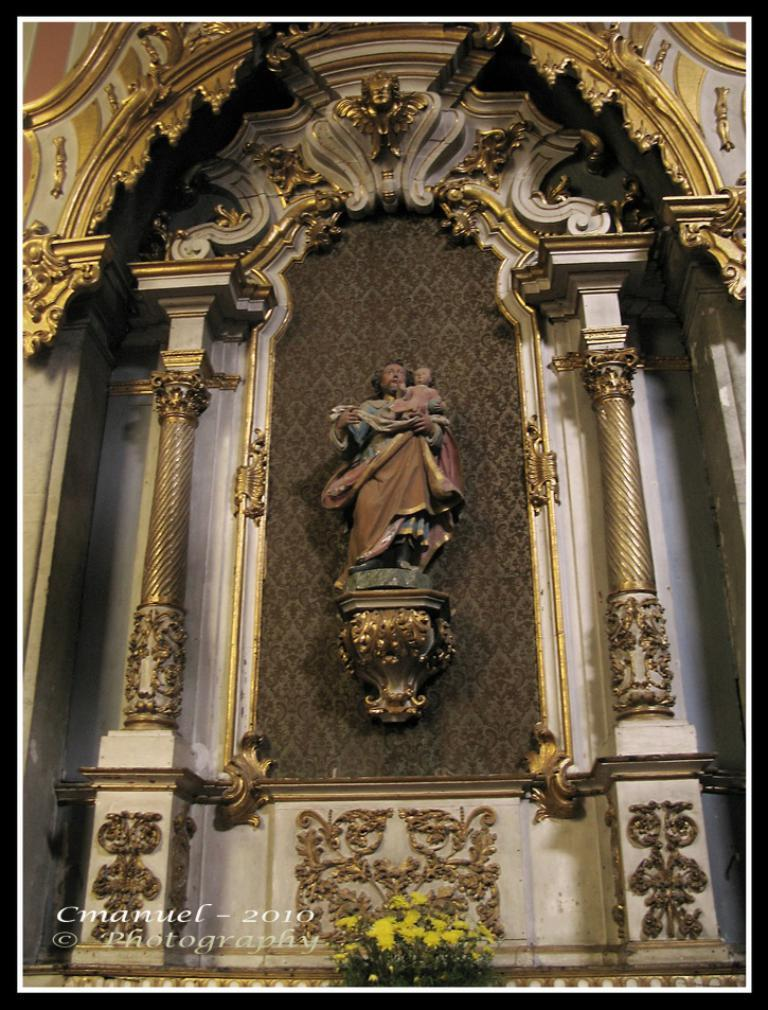What can be seen on the wall in the image? There are sculptures and designs on a wall in the image. What type of natural elements are visible in the image? There are flowers visible in the image. Where is the hydrant located in the image? There is no hydrant present in the image. What scientific discoveries are depicted in the sculptures and designs on the wall? The image does not depict any scientific discoveries; it only shows sculptures and designs on a wall. 